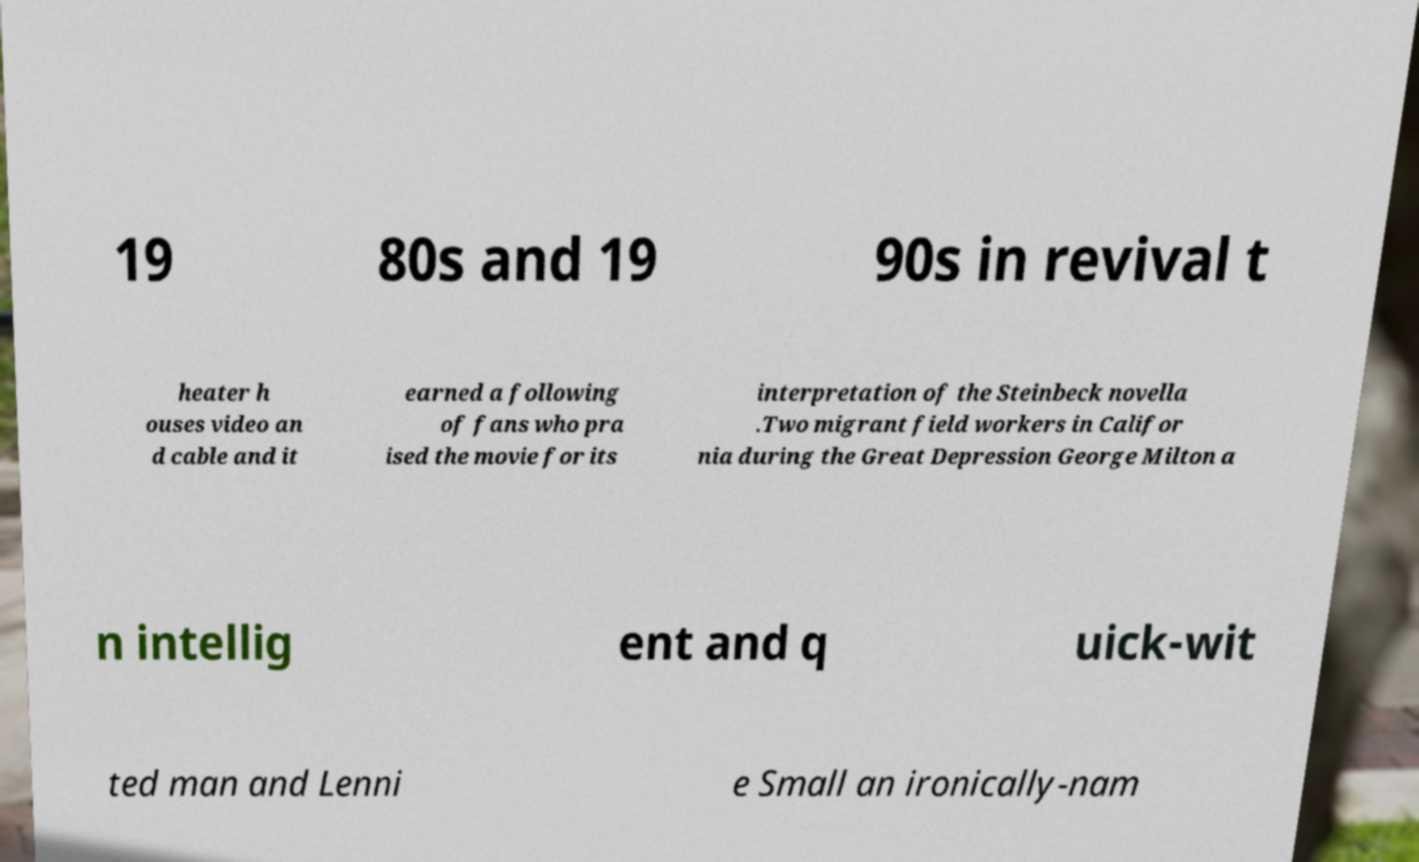Can you accurately transcribe the text from the provided image for me? 19 80s and 19 90s in revival t heater h ouses video an d cable and it earned a following of fans who pra ised the movie for its interpretation of the Steinbeck novella .Two migrant field workers in Califor nia during the Great Depression George Milton a n intellig ent and q uick-wit ted man and Lenni e Small an ironically-nam 